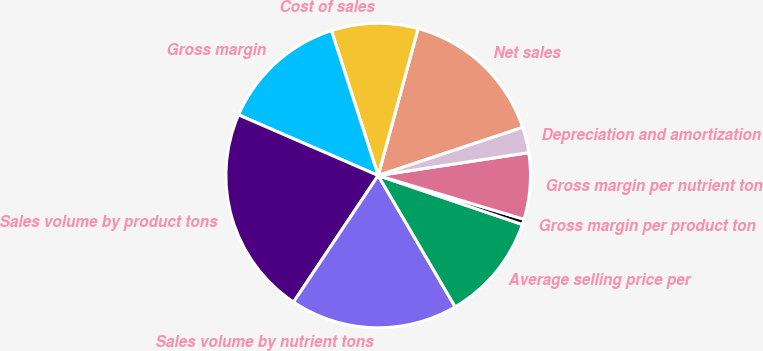Convert chart to OTSL. <chart><loc_0><loc_0><loc_500><loc_500><pie_chart><fcel>Net sales<fcel>Cost of sales<fcel>Gross margin<fcel>Sales volume by product tons<fcel>Sales volume by nutrient tons<fcel>Average selling price per<fcel>Gross margin per product ton<fcel>Gross margin per nutrient ton<fcel>Depreciation and amortization<nl><fcel>15.66%<fcel>9.19%<fcel>13.51%<fcel>22.14%<fcel>17.82%<fcel>11.35%<fcel>0.57%<fcel>7.04%<fcel>2.72%<nl></chart> 